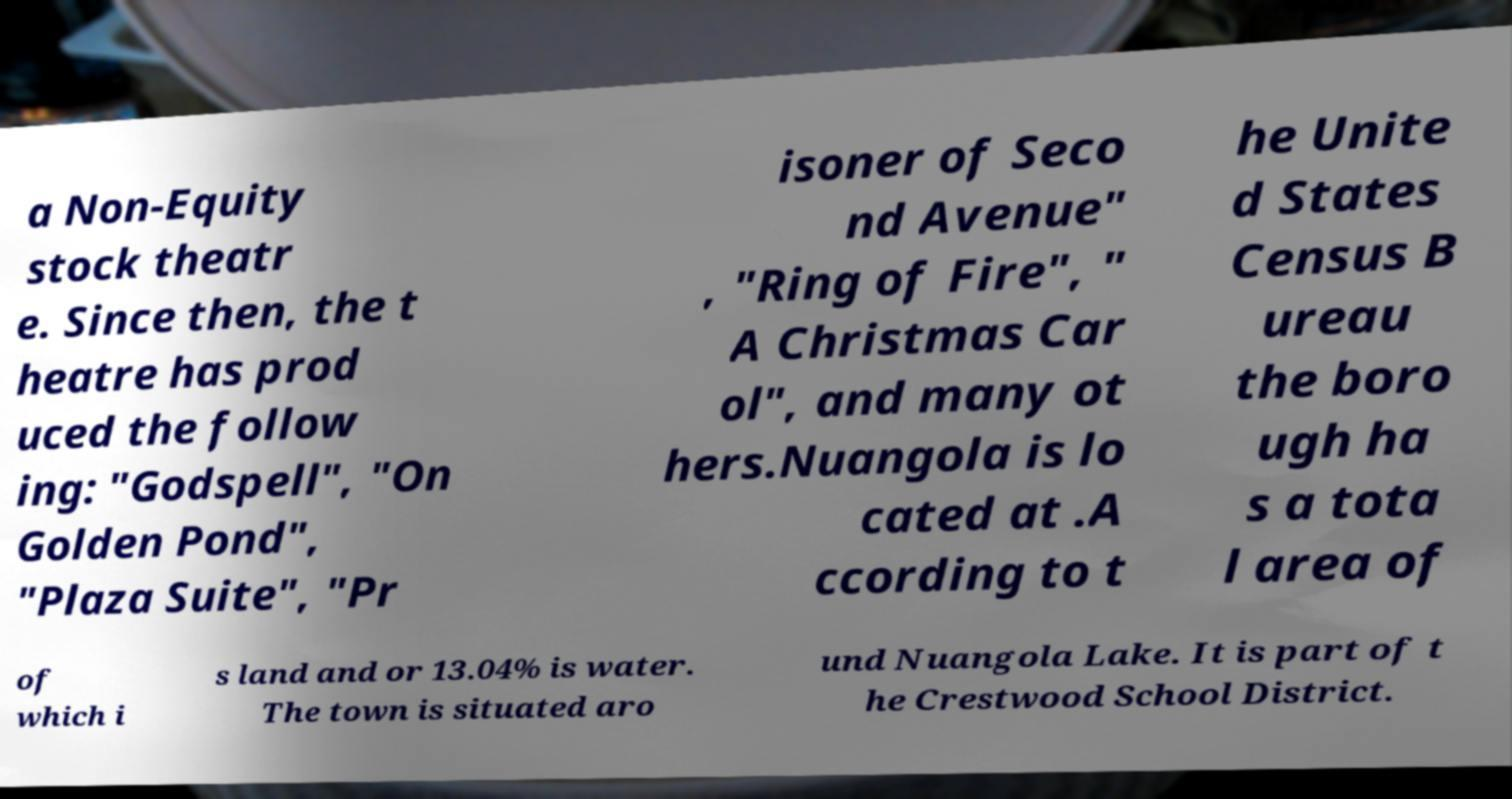There's text embedded in this image that I need extracted. Can you transcribe it verbatim? a Non-Equity stock theatr e. Since then, the t heatre has prod uced the follow ing: "Godspell", "On Golden Pond", "Plaza Suite", "Pr isoner of Seco nd Avenue" , "Ring of Fire", " A Christmas Car ol", and many ot hers.Nuangola is lo cated at .A ccording to t he Unite d States Census B ureau the boro ugh ha s a tota l area of of which i s land and or 13.04% is water. The town is situated aro und Nuangola Lake. It is part of t he Crestwood School District. 